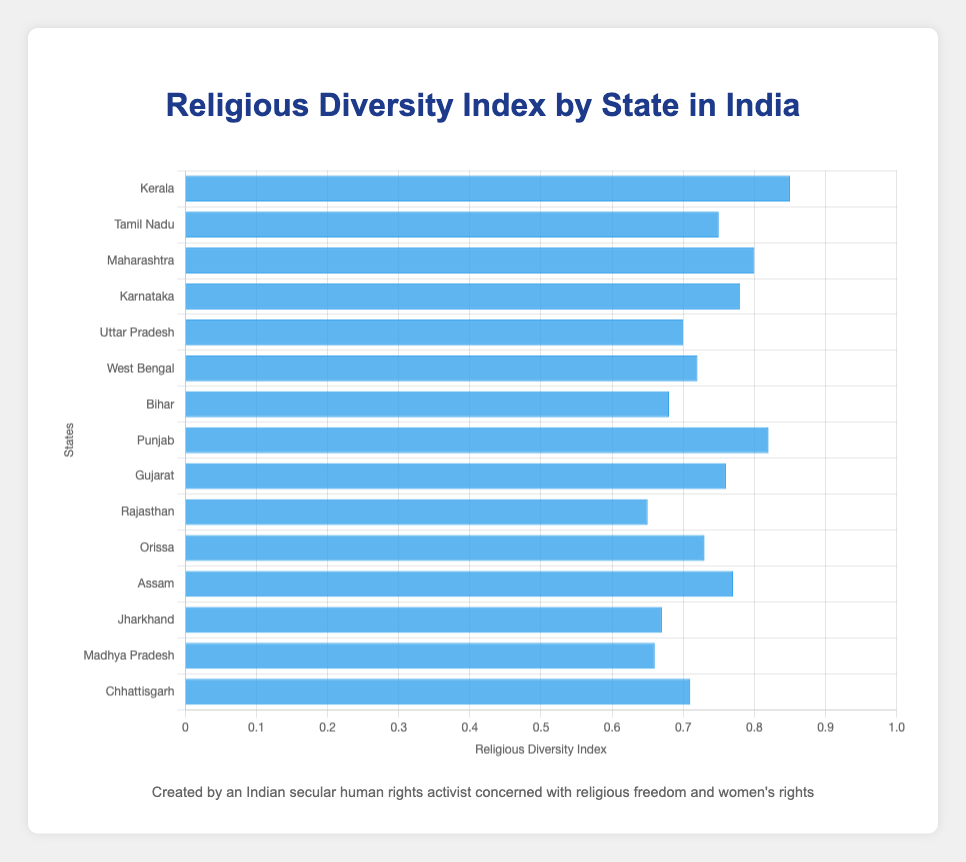Which state has the highest Religious Diversity Index? To determine this, we visually examine which bar is the tallest. The bar representing Kerala is the tallest.
Answer: Kerala Which state has the lowest Religious Diversity Index? By looking for the shortest bar, we find that Rajasthan has the shortest bar.
Answer: Rajasthan What is the difference in the Religious Diversity Index between Kerala and Bihar? Kerala has an index of 0.85, and Bihar has an index of 0.68. The difference is calculated as 0.85 - 0.68.
Answer: 0.17 What is the average Religious Diversity Index of Maharashtra, Karnataka, and Gujarat? The indices are 0.80, 0.78, and 0.76 respectively. Summing them gives 0.80 + 0.78 + 0.76 = 2.34. Dividing by 3, the average is 2.34 / 3.
Answer: 0.78 Which state has a higher Religious Diversity Index: Assam or West Bengal? Compare the heights of the bars for Assam (0.77) and West Bengal (0.72). Assam's bar is taller.
Answer: Assam What is the sum of the Religious Diversity Index for Tamil Nadu and Orissa? The indices are 0.75 for Tamil Nadu and 0.73 for Orissa. Summing them, 0.75 + 0.73 = 1.48.
Answer: 1.48 How many states have a Religious Diversity Index greater than 0.75? Visually inspect the bars and count the states: Kerala (0.85), Maharashtra (0.80), Karnataka (0.78), Punjab (0.82), Gujarat (0.76), Assam (0.77).
Answer: 6 Which state has a slightly higher Religious Diversity Index: Uttar Pradesh or Chhattisgarh? Compare the heights of the bars for Uttar Pradesh (0.70) and Chhattisgarh (0.71). Chhattisgarh's bar is slightly taller.
Answer: Chhattisgarh 